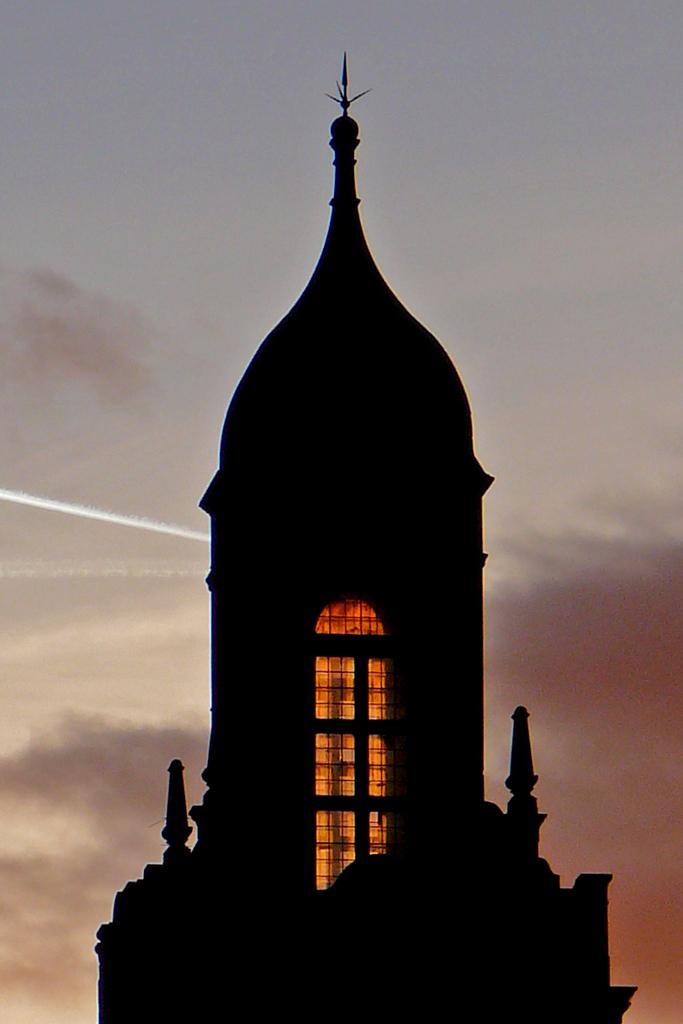Could you give a brief overview of what you see in this image? There is a building with windows. In the back there is sky. Inside the building there is light. 